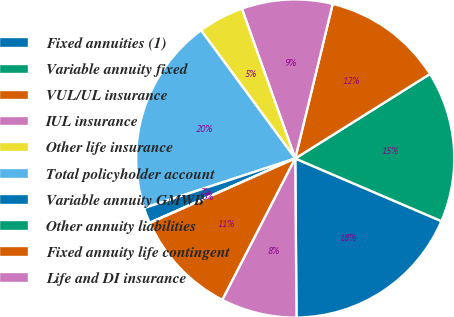Convert chart. <chart><loc_0><loc_0><loc_500><loc_500><pie_chart><fcel>Fixed annuities (1)<fcel>Variable annuity fixed<fcel>VUL/UL insurance<fcel>IUL insurance<fcel>Other life insurance<fcel>Total policyholder account<fcel>Variable annuity GMWB<fcel>Other annuity liabilities<fcel>Fixed annuity life contingent<fcel>Life and DI insurance<nl><fcel>18.43%<fcel>15.36%<fcel>12.3%<fcel>9.23%<fcel>4.64%<fcel>19.96%<fcel>1.57%<fcel>0.04%<fcel>10.77%<fcel>7.7%<nl></chart> 